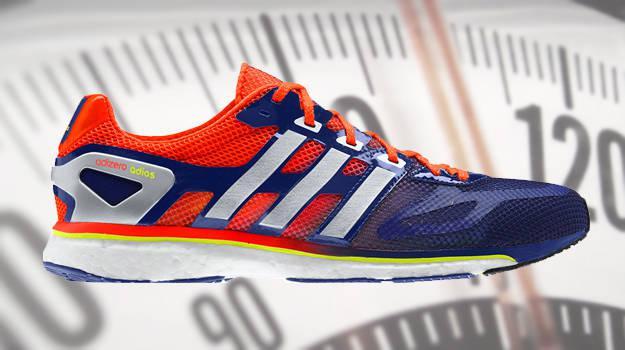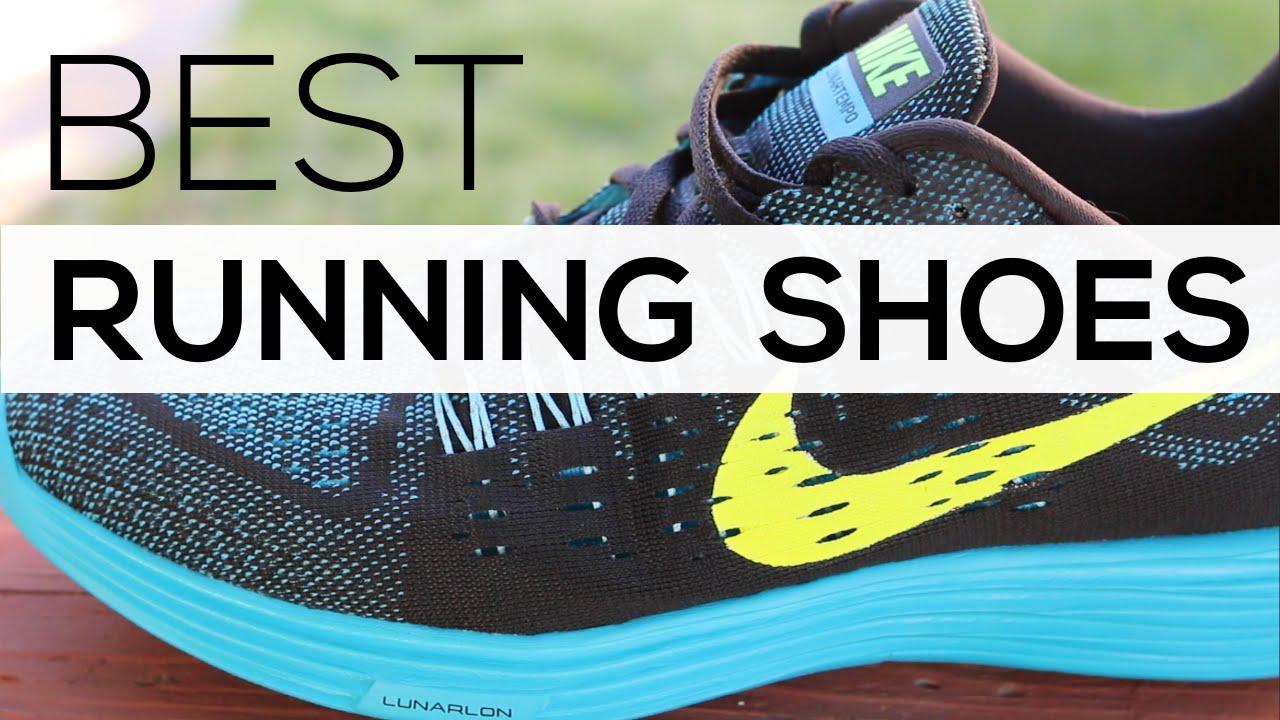The first image is the image on the left, the second image is the image on the right. Assess this claim about the two images: "One image shows only one pair of black shoes with white and yellow trim.". Correct or not? Answer yes or no. No. 